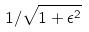Convert formula to latex. <formula><loc_0><loc_0><loc_500><loc_500>1 / \sqrt { 1 + \epsilon ^ { 2 } }</formula> 